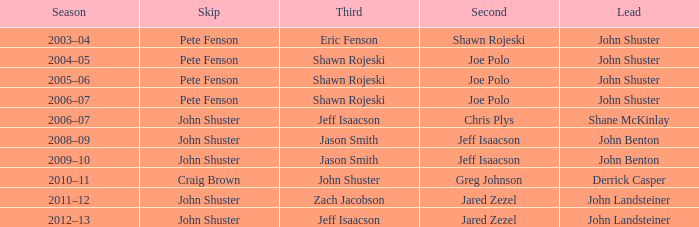While shane mckinlay was leading, who was the runner-up? Chris Plys. 